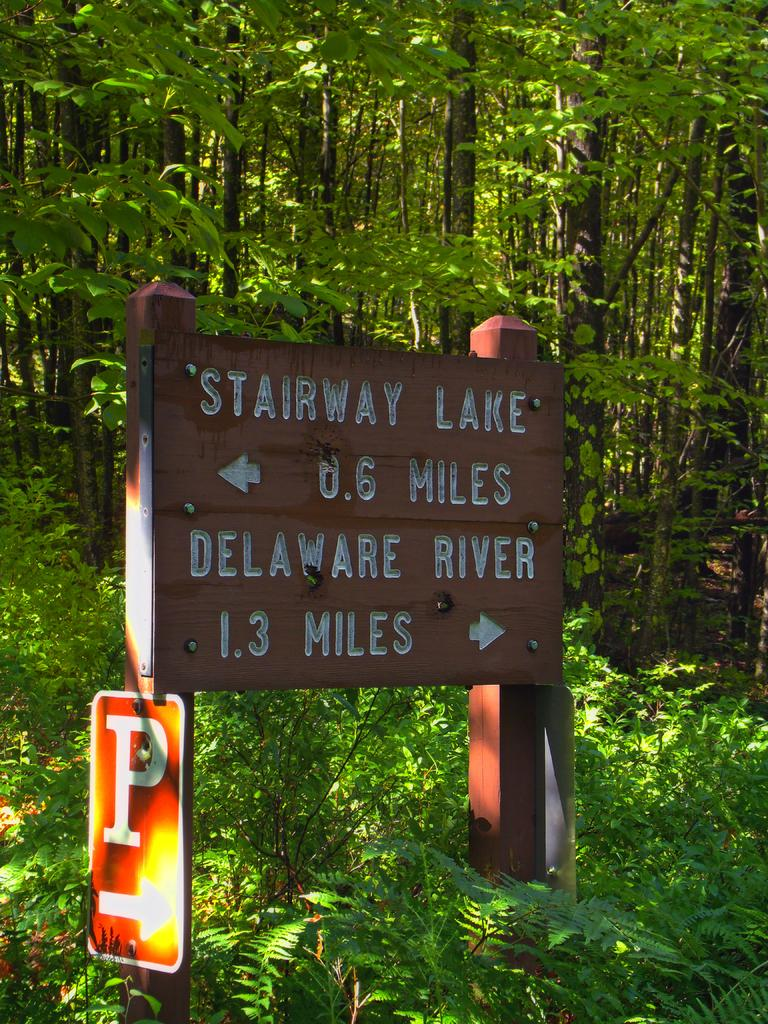What objects are present in the image that provide information? There are sign boards in the image that provide information. What type of natural elements can be seen in the image? Plants and trees are visible in the image. Can you read any text in the image? Yes, there is text visible on the sign boards. Is there a birthday celebration happening in the image? There is no indication of a birthday celebration in the image. Can you see the governor in the image? There is no mention of a governor or any political figure in the image. 